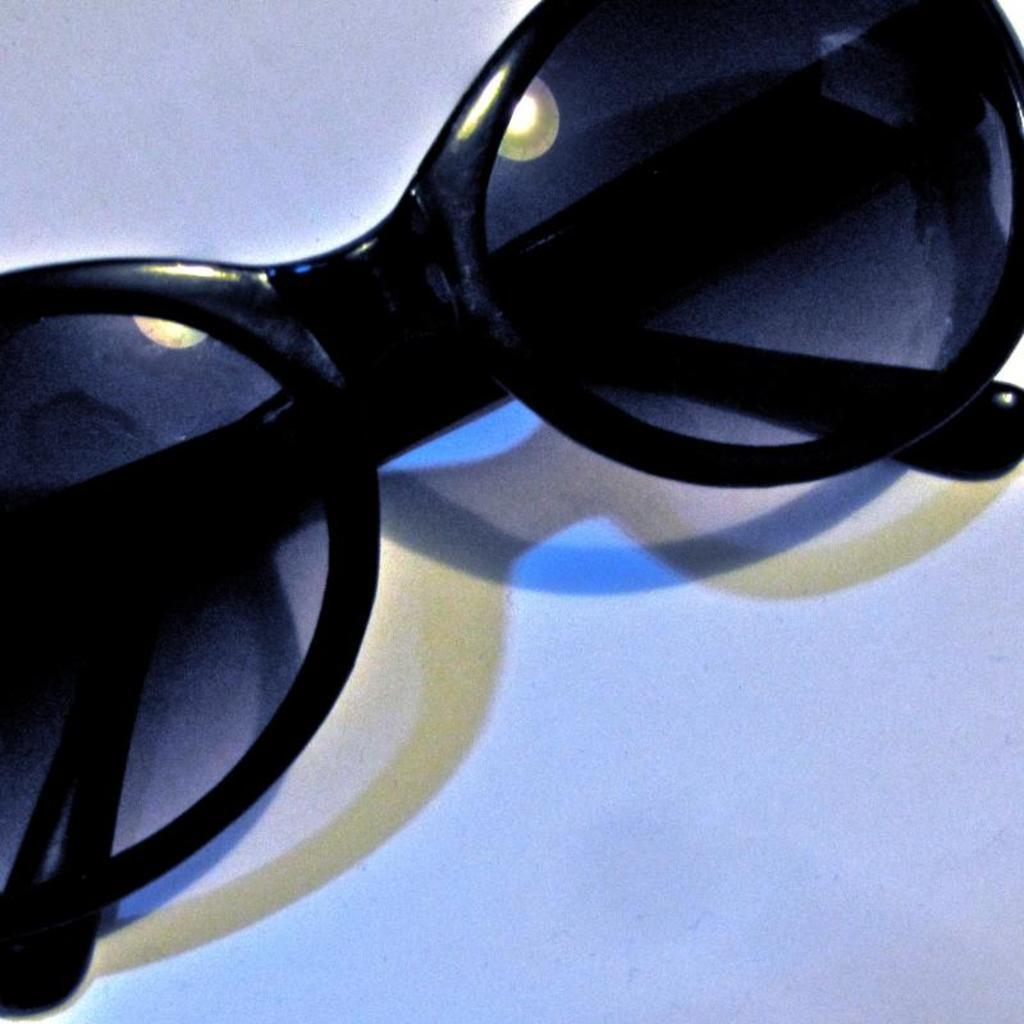What is the main subject of the image? The main subject of the image is a Google logo. What is the background color of the image? The Google logo is on a white surface. How many dogs are sitting on the Google logo in the image? There are no dogs present in the image; it features only the Google logo on a white surface. What type of bird can be seen flying over the Google logo in the image? There is no bird present in the image; it features only the Google logo on a white surface. 